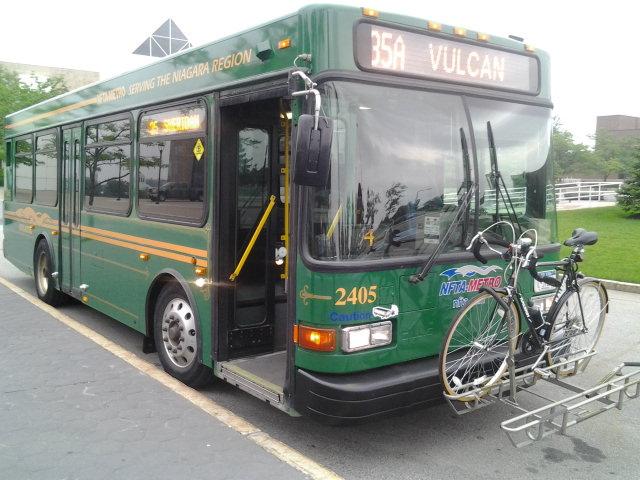How many bicycles do you see?
Be succinct. 1. What color is the bus?
Short answer required. Green. Is the bus a public city bus?
Short answer required. Yes. Where is this bus headed?
Answer briefly. Vulcan. What is the bus number?
Write a very short answer. 2405. What color is the bike on the front of the bus?
Give a very brief answer. Black. Is the bus in motion?
Concise answer only. No. What is the rack in the front of the bus for?
Short answer required. Bikes. What is the number painted on the bus?
Be succinct. 2405. What color is the front of the bus?
Write a very short answer. Green. How many people are standing outside of the bus?
Concise answer only. 0. What is hanging over the bus?
Write a very short answer. Bike. Where is the bus going?
Answer briefly. Vulcan. What is the number on the bus?
Keep it brief. 2405. 